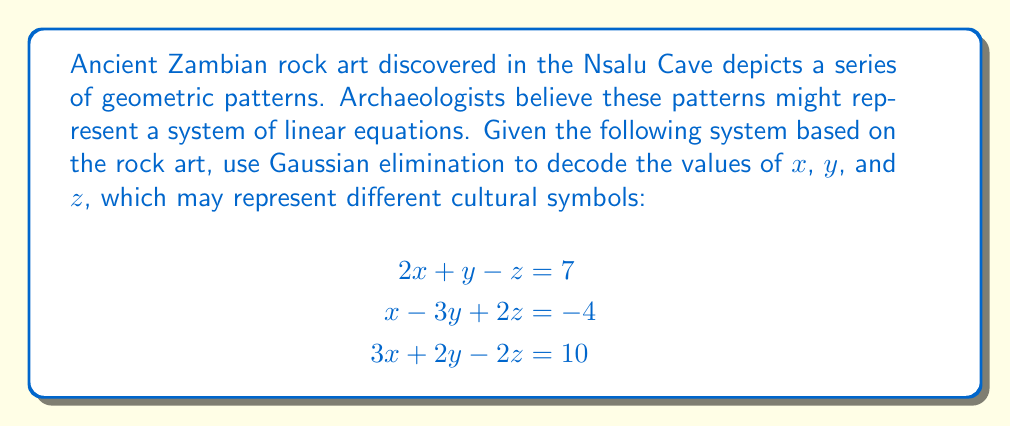Show me your answer to this math problem. Let's solve this system using Gaussian elimination, a method that might reflect how ancient Zambians could have solved complex problems:

1. Write the augmented matrix:
   $$\begin{bmatrix}
   2 & 1 & -1 & 7 \\
   1 & -3 & 2 & -4 \\
   3 & 2 & -2 & 10
   \end{bmatrix}$$

2. Use $R_1$ as pivot row. Subtract 1/2 $R_1$ from $R_2$, and 3/2 $R_1$ from $R_3$:
   $$\begin{bmatrix}
   2 & 1 & -1 & 7 \\
   0 & -3.5 & 2.5 & -7.5 \\
   0 & 0.5 & -0.5 & 0.5
   \end{bmatrix}$$

3. Use $R_2$ as pivot row. Add 1/7 $R_2$ to $R_3$:
   $$\begin{bmatrix}
   2 & 1 & -1 & 7 \\
   0 & -3.5 & 2.5 & -7.5 \\
   0 & 0 & -0.214 & -0.571
   \end{bmatrix}$$

4. Back-substitute to find $z$:
   $-0.214z = -0.571$
   $z = 2.667$

5. Substitute $z$ into $R_2$ to find $y$:
   $-3.5y + 2.5(2.667) = -7.5$
   $-3.5y = -14.167$
   $y = 4.048$

6. Substitute $y$ and $z$ into $R_1$ to find $x$:
   $2x + 4.048 - 2.667 = 7$
   $2x = 5.619$
   $x = 2.810$
Answer: $x \approx 2.810$, $y \approx 4.048$, $z \approx 2.667$ 